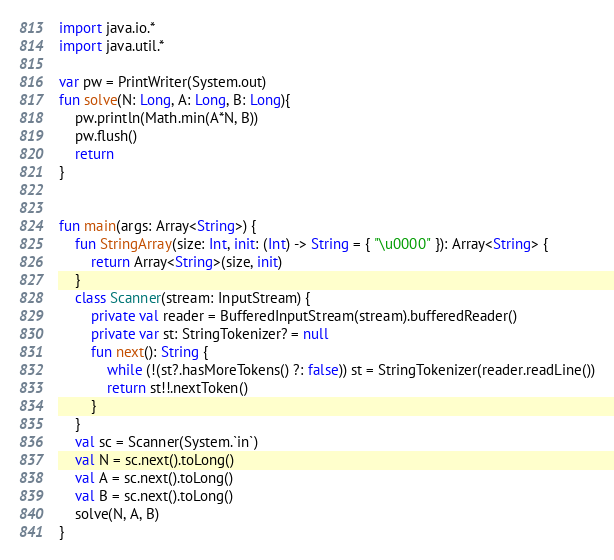Convert code to text. <code><loc_0><loc_0><loc_500><loc_500><_Kotlin_>import java.io.*
import java.util.*

var pw = PrintWriter(System.out)
fun solve(N: Long, A: Long, B: Long){
    pw.println(Math.min(A*N, B))
    pw.flush()
    return
}


fun main(args: Array<String>) {
    fun StringArray(size: Int, init: (Int) -> String = { "\u0000" }): Array<String> {
        return Array<String>(size, init)
    }
    class Scanner(stream: InputStream) {
        private val reader = BufferedInputStream(stream).bufferedReader()
        private var st: StringTokenizer? = null
        fun next(): String {
            while (!(st?.hasMoreTokens() ?: false)) st = StringTokenizer(reader.readLine())
            return st!!.nextToken()
        }
    }
    val sc = Scanner(System.`in`)
    val N = sc.next().toLong()
    val A = sc.next().toLong()
    val B = sc.next().toLong()
    solve(N, A, B)
}


</code> 